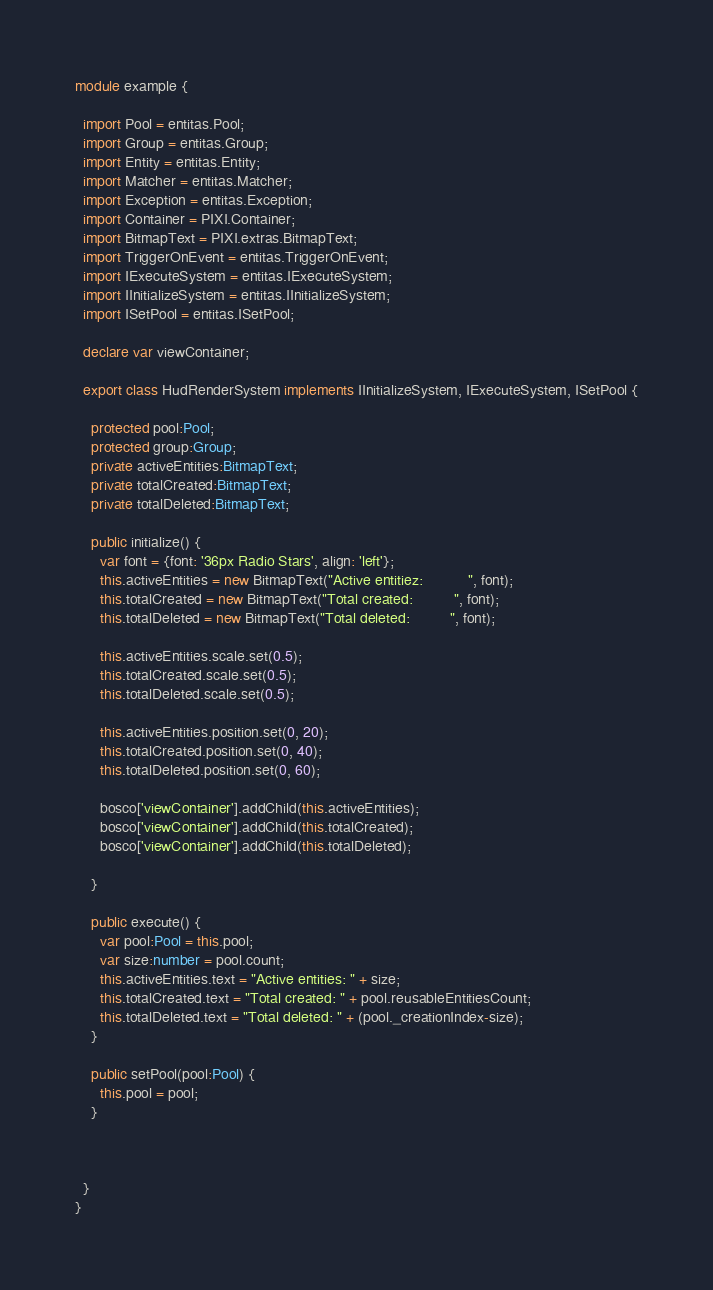Convert code to text. <code><loc_0><loc_0><loc_500><loc_500><_TypeScript_>module example {

  import Pool = entitas.Pool;
  import Group = entitas.Group;
  import Entity = entitas.Entity;
  import Matcher = entitas.Matcher;
  import Exception = entitas.Exception;
  import Container = PIXI.Container;
  import BitmapText = PIXI.extras.BitmapText;
  import TriggerOnEvent = entitas.TriggerOnEvent;
  import IExecuteSystem = entitas.IExecuteSystem;
  import IInitializeSystem = entitas.IInitializeSystem;
  import ISetPool = entitas.ISetPool;

  declare var viewContainer;

  export class HudRenderSystem implements IInitializeSystem, IExecuteSystem, ISetPool {

    protected pool:Pool;
    protected group:Group;
    private activeEntities:BitmapText;
    private totalCreated:BitmapText;
    private totalDeleted:BitmapText;

    public initialize() {
      var font = {font: '36px Radio Stars', align: 'left'};
      this.activeEntities = new BitmapText("Active entitiez:           ", font);
      this.totalCreated = new BitmapText("Total created:          ", font);
      this.totalDeleted = new BitmapText("Total deleted:          ", font);

      this.activeEntities.scale.set(0.5);
      this.totalCreated.scale.set(0.5);
      this.totalDeleted.scale.set(0.5);

      this.activeEntities.position.set(0, 20);
      this.totalCreated.position.set(0, 40);
      this.totalDeleted.position.set(0, 60);

      bosco['viewContainer'].addChild(this.activeEntities);
      bosco['viewContainer'].addChild(this.totalCreated);
      bosco['viewContainer'].addChild(this.totalDeleted);

    }

    public execute() {
      var pool:Pool = this.pool;
      var size:number = pool.count;
      this.activeEntities.text = "Active entities: " + size;
      this.totalCreated.text = "Total created: " + pool.reusableEntitiesCount;
      this.totalDeleted.text = "Total deleted: " + (pool._creationIndex-size);
    }

    public setPool(pool:Pool) {
      this.pool = pool;
    }



  }
}
</code> 